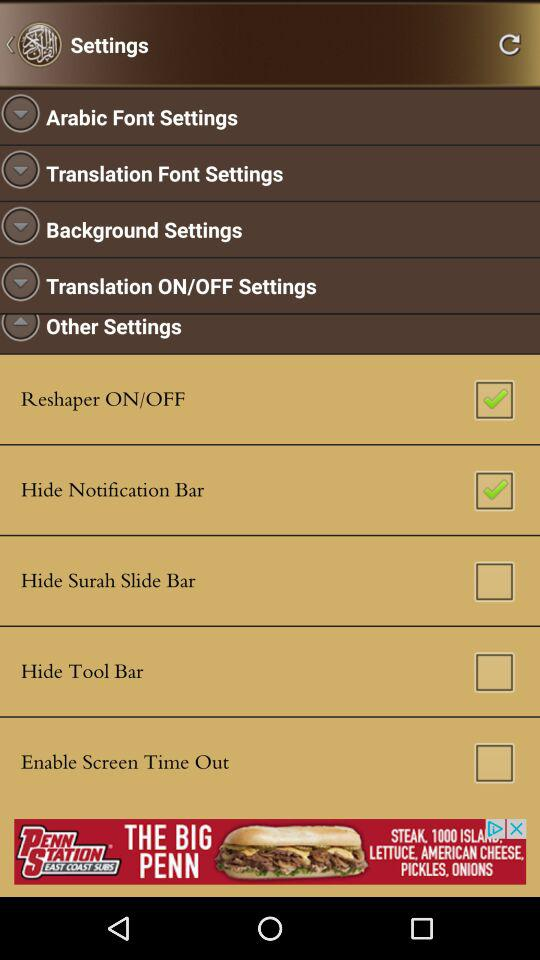What is the status of "Reshaper ON/OFF"? The status of "Reshaper ON/OFF" is "on". 